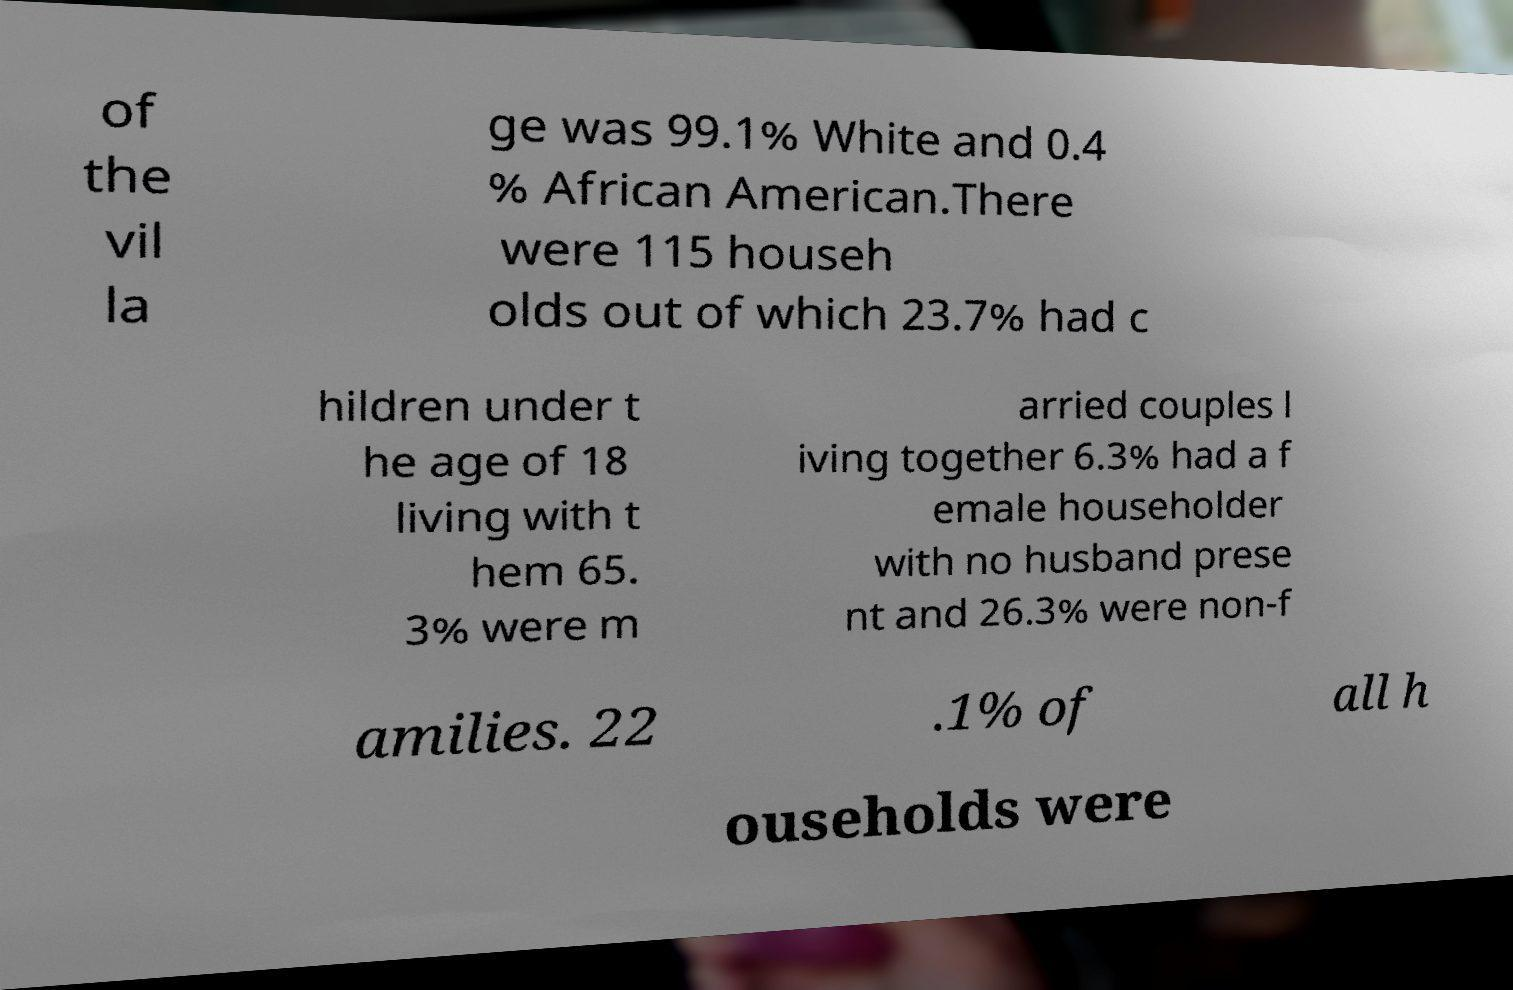Can you read and provide the text displayed in the image?This photo seems to have some interesting text. Can you extract and type it out for me? of the vil la ge was 99.1% White and 0.4 % African American.There were 115 househ olds out of which 23.7% had c hildren under t he age of 18 living with t hem 65. 3% were m arried couples l iving together 6.3% had a f emale householder with no husband prese nt and 26.3% were non-f amilies. 22 .1% of all h ouseholds were 